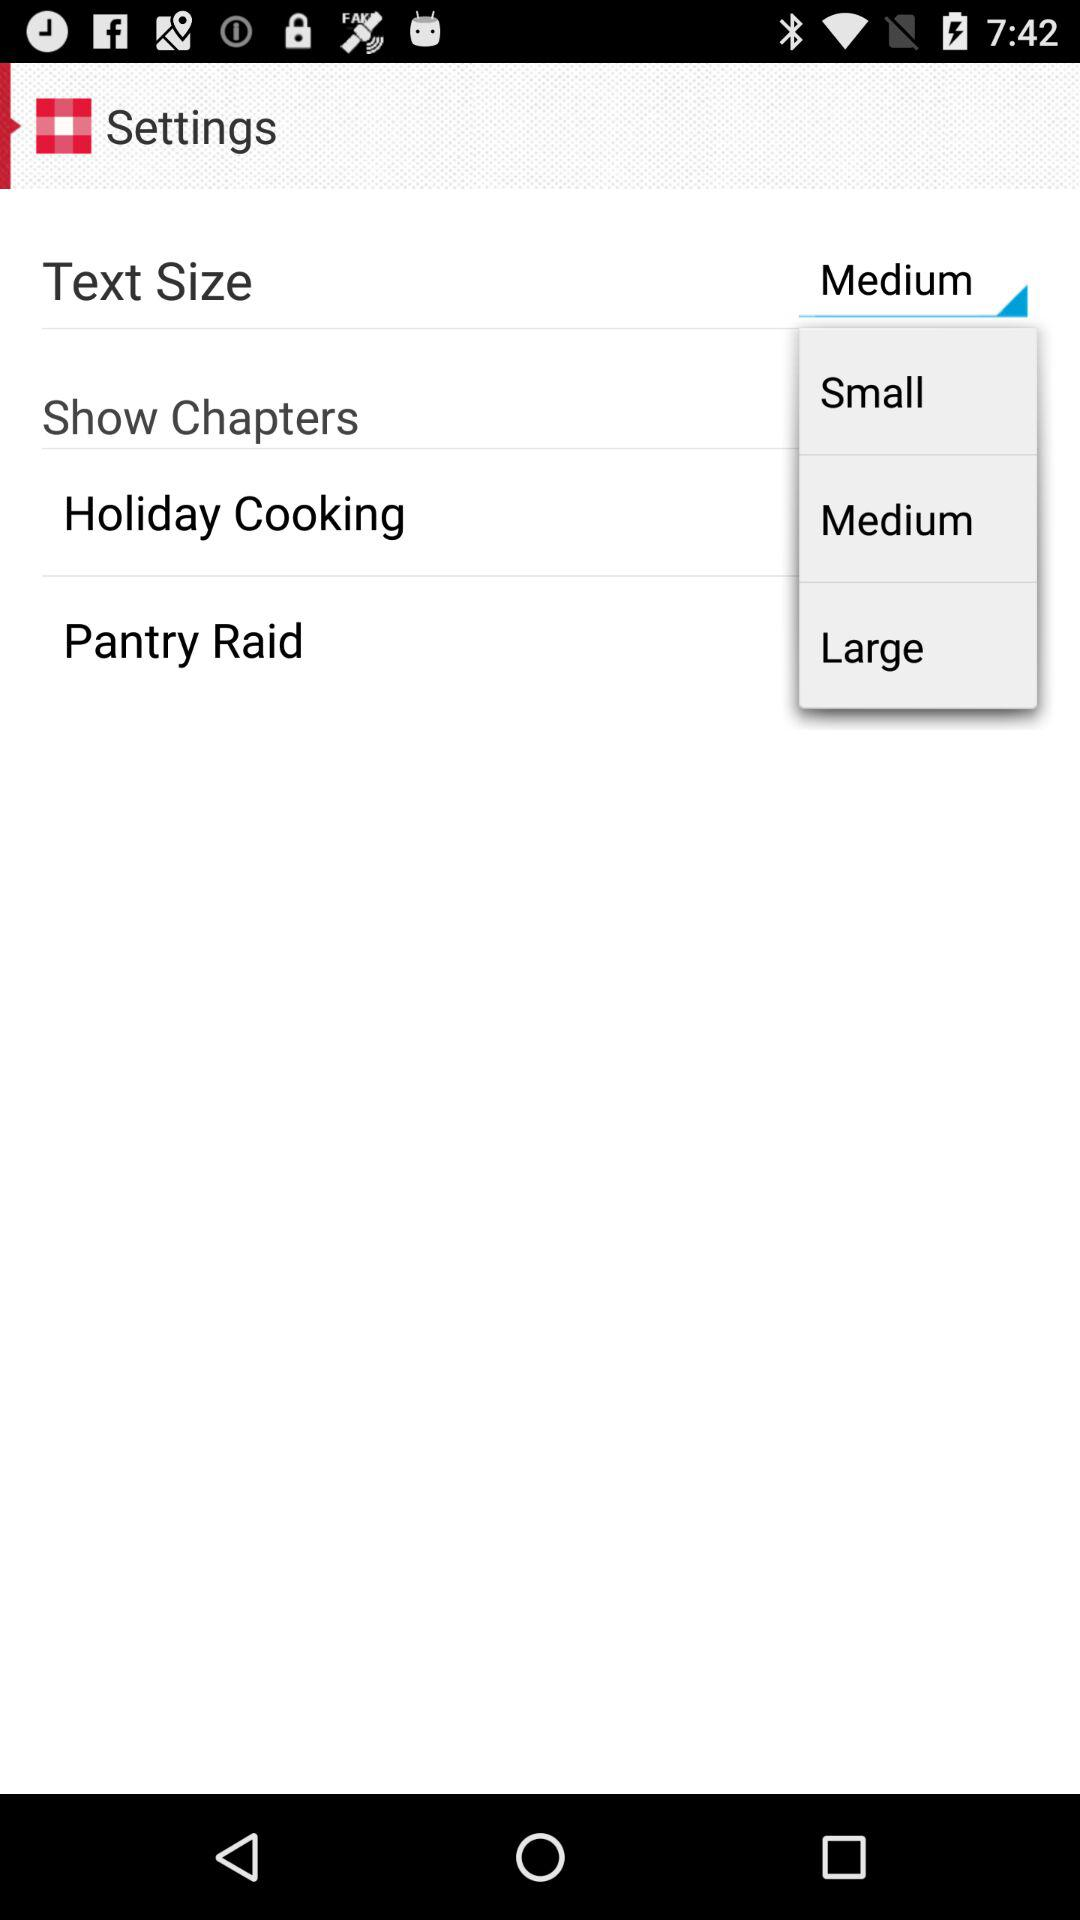How many text size options are there?
Answer the question using a single word or phrase. 3 